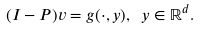<formula> <loc_0><loc_0><loc_500><loc_500>( I - P ) v = g ( \cdot , y ) , \ y \in { \mathbb { R } } ^ { d } .</formula> 